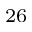<formula> <loc_0><loc_0><loc_500><loc_500>^ { 2 6 }</formula> 